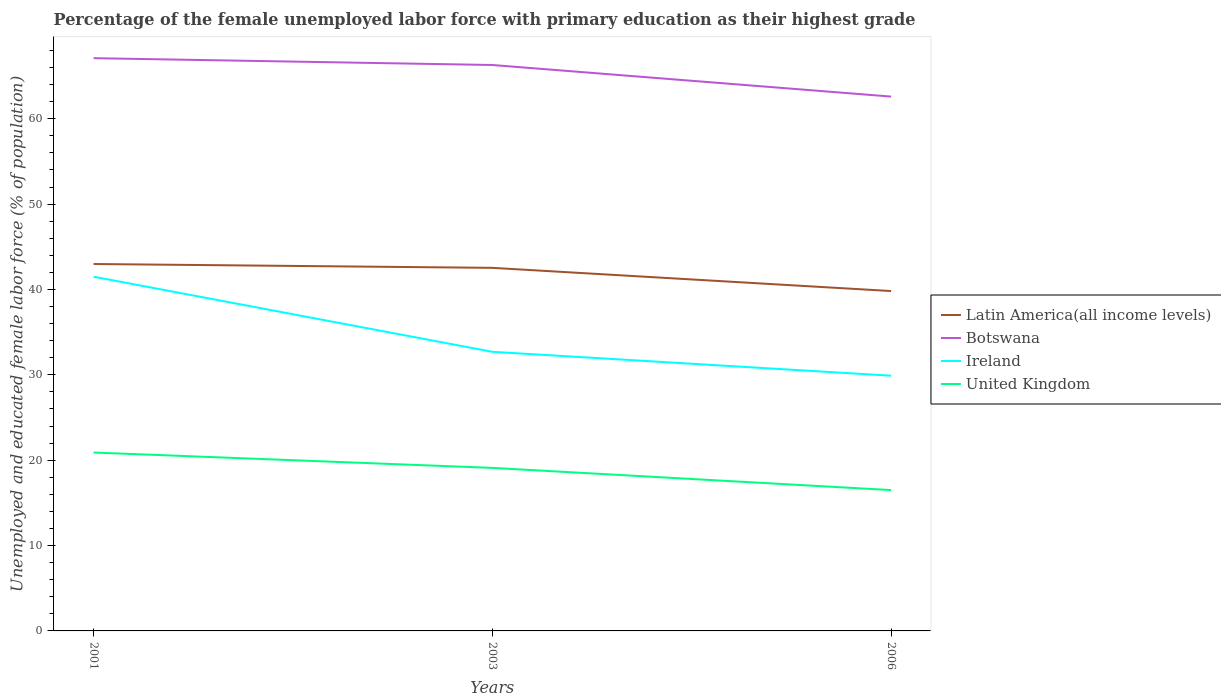How many different coloured lines are there?
Ensure brevity in your answer.  4. Does the line corresponding to United Kingdom intersect with the line corresponding to Ireland?
Your answer should be compact. No. In which year was the percentage of the unemployed female labor force with primary education in United Kingdom maximum?
Keep it short and to the point. 2006. What is the total percentage of the unemployed female labor force with primary education in Latin America(all income levels) in the graph?
Your answer should be compact. 3.17. What is the difference between the highest and the second highest percentage of the unemployed female labor force with primary education in Ireland?
Make the answer very short. 11.6. Is the percentage of the unemployed female labor force with primary education in Botswana strictly greater than the percentage of the unemployed female labor force with primary education in Ireland over the years?
Offer a very short reply. No. What is the difference between two consecutive major ticks on the Y-axis?
Your response must be concise. 10. Does the graph contain grids?
Give a very brief answer. No. How many legend labels are there?
Provide a succinct answer. 4. What is the title of the graph?
Ensure brevity in your answer.  Percentage of the female unemployed labor force with primary education as their highest grade. What is the label or title of the Y-axis?
Keep it short and to the point. Unemployed and educated female labor force (% of population). What is the Unemployed and educated female labor force (% of population) in Latin America(all income levels) in 2001?
Provide a short and direct response. 42.99. What is the Unemployed and educated female labor force (% of population) of Botswana in 2001?
Provide a short and direct response. 67.1. What is the Unemployed and educated female labor force (% of population) of Ireland in 2001?
Ensure brevity in your answer.  41.5. What is the Unemployed and educated female labor force (% of population) of United Kingdom in 2001?
Provide a succinct answer. 20.9. What is the Unemployed and educated female labor force (% of population) of Latin America(all income levels) in 2003?
Give a very brief answer. 42.54. What is the Unemployed and educated female labor force (% of population) of Botswana in 2003?
Keep it short and to the point. 66.3. What is the Unemployed and educated female labor force (% of population) in Ireland in 2003?
Keep it short and to the point. 32.7. What is the Unemployed and educated female labor force (% of population) in United Kingdom in 2003?
Your answer should be compact. 19.1. What is the Unemployed and educated female labor force (% of population) in Latin America(all income levels) in 2006?
Make the answer very short. 39.82. What is the Unemployed and educated female labor force (% of population) in Botswana in 2006?
Offer a terse response. 62.6. What is the Unemployed and educated female labor force (% of population) in Ireland in 2006?
Give a very brief answer. 29.9. What is the Unemployed and educated female labor force (% of population) in United Kingdom in 2006?
Your response must be concise. 16.5. Across all years, what is the maximum Unemployed and educated female labor force (% of population) of Latin America(all income levels)?
Your answer should be very brief. 42.99. Across all years, what is the maximum Unemployed and educated female labor force (% of population) in Botswana?
Your answer should be very brief. 67.1. Across all years, what is the maximum Unemployed and educated female labor force (% of population) in Ireland?
Ensure brevity in your answer.  41.5. Across all years, what is the maximum Unemployed and educated female labor force (% of population) of United Kingdom?
Offer a terse response. 20.9. Across all years, what is the minimum Unemployed and educated female labor force (% of population) in Latin America(all income levels)?
Provide a succinct answer. 39.82. Across all years, what is the minimum Unemployed and educated female labor force (% of population) in Botswana?
Offer a terse response. 62.6. Across all years, what is the minimum Unemployed and educated female labor force (% of population) of Ireland?
Offer a very short reply. 29.9. What is the total Unemployed and educated female labor force (% of population) in Latin America(all income levels) in the graph?
Ensure brevity in your answer.  125.34. What is the total Unemployed and educated female labor force (% of population) of Botswana in the graph?
Keep it short and to the point. 196. What is the total Unemployed and educated female labor force (% of population) of Ireland in the graph?
Provide a succinct answer. 104.1. What is the total Unemployed and educated female labor force (% of population) in United Kingdom in the graph?
Your answer should be compact. 56.5. What is the difference between the Unemployed and educated female labor force (% of population) of Latin America(all income levels) in 2001 and that in 2003?
Offer a terse response. 0.45. What is the difference between the Unemployed and educated female labor force (% of population) of Ireland in 2001 and that in 2003?
Ensure brevity in your answer.  8.8. What is the difference between the Unemployed and educated female labor force (% of population) in United Kingdom in 2001 and that in 2003?
Offer a very short reply. 1.8. What is the difference between the Unemployed and educated female labor force (% of population) of Latin America(all income levels) in 2001 and that in 2006?
Your answer should be compact. 3.17. What is the difference between the Unemployed and educated female labor force (% of population) in Botswana in 2001 and that in 2006?
Give a very brief answer. 4.5. What is the difference between the Unemployed and educated female labor force (% of population) of Latin America(all income levels) in 2003 and that in 2006?
Ensure brevity in your answer.  2.72. What is the difference between the Unemployed and educated female labor force (% of population) of Botswana in 2003 and that in 2006?
Ensure brevity in your answer.  3.7. What is the difference between the Unemployed and educated female labor force (% of population) of United Kingdom in 2003 and that in 2006?
Offer a very short reply. 2.6. What is the difference between the Unemployed and educated female labor force (% of population) of Latin America(all income levels) in 2001 and the Unemployed and educated female labor force (% of population) of Botswana in 2003?
Your answer should be very brief. -23.31. What is the difference between the Unemployed and educated female labor force (% of population) in Latin America(all income levels) in 2001 and the Unemployed and educated female labor force (% of population) in Ireland in 2003?
Offer a terse response. 10.29. What is the difference between the Unemployed and educated female labor force (% of population) in Latin America(all income levels) in 2001 and the Unemployed and educated female labor force (% of population) in United Kingdom in 2003?
Your answer should be very brief. 23.89. What is the difference between the Unemployed and educated female labor force (% of population) of Botswana in 2001 and the Unemployed and educated female labor force (% of population) of Ireland in 2003?
Your answer should be very brief. 34.4. What is the difference between the Unemployed and educated female labor force (% of population) of Ireland in 2001 and the Unemployed and educated female labor force (% of population) of United Kingdom in 2003?
Your answer should be compact. 22.4. What is the difference between the Unemployed and educated female labor force (% of population) of Latin America(all income levels) in 2001 and the Unemployed and educated female labor force (% of population) of Botswana in 2006?
Make the answer very short. -19.61. What is the difference between the Unemployed and educated female labor force (% of population) in Latin America(all income levels) in 2001 and the Unemployed and educated female labor force (% of population) in Ireland in 2006?
Give a very brief answer. 13.09. What is the difference between the Unemployed and educated female labor force (% of population) of Latin America(all income levels) in 2001 and the Unemployed and educated female labor force (% of population) of United Kingdom in 2006?
Offer a terse response. 26.49. What is the difference between the Unemployed and educated female labor force (% of population) of Botswana in 2001 and the Unemployed and educated female labor force (% of population) of Ireland in 2006?
Make the answer very short. 37.2. What is the difference between the Unemployed and educated female labor force (% of population) in Botswana in 2001 and the Unemployed and educated female labor force (% of population) in United Kingdom in 2006?
Offer a very short reply. 50.6. What is the difference between the Unemployed and educated female labor force (% of population) of Ireland in 2001 and the Unemployed and educated female labor force (% of population) of United Kingdom in 2006?
Keep it short and to the point. 25. What is the difference between the Unemployed and educated female labor force (% of population) of Latin America(all income levels) in 2003 and the Unemployed and educated female labor force (% of population) of Botswana in 2006?
Provide a succinct answer. -20.06. What is the difference between the Unemployed and educated female labor force (% of population) in Latin America(all income levels) in 2003 and the Unemployed and educated female labor force (% of population) in Ireland in 2006?
Your answer should be compact. 12.64. What is the difference between the Unemployed and educated female labor force (% of population) of Latin America(all income levels) in 2003 and the Unemployed and educated female labor force (% of population) of United Kingdom in 2006?
Offer a terse response. 26.04. What is the difference between the Unemployed and educated female labor force (% of population) of Botswana in 2003 and the Unemployed and educated female labor force (% of population) of Ireland in 2006?
Make the answer very short. 36.4. What is the difference between the Unemployed and educated female labor force (% of population) of Botswana in 2003 and the Unemployed and educated female labor force (% of population) of United Kingdom in 2006?
Your answer should be very brief. 49.8. What is the difference between the Unemployed and educated female labor force (% of population) in Ireland in 2003 and the Unemployed and educated female labor force (% of population) in United Kingdom in 2006?
Provide a short and direct response. 16.2. What is the average Unemployed and educated female labor force (% of population) in Latin America(all income levels) per year?
Your answer should be very brief. 41.78. What is the average Unemployed and educated female labor force (% of population) in Botswana per year?
Provide a succinct answer. 65.33. What is the average Unemployed and educated female labor force (% of population) of Ireland per year?
Offer a very short reply. 34.7. What is the average Unemployed and educated female labor force (% of population) of United Kingdom per year?
Make the answer very short. 18.83. In the year 2001, what is the difference between the Unemployed and educated female labor force (% of population) in Latin America(all income levels) and Unemployed and educated female labor force (% of population) in Botswana?
Your response must be concise. -24.11. In the year 2001, what is the difference between the Unemployed and educated female labor force (% of population) of Latin America(all income levels) and Unemployed and educated female labor force (% of population) of Ireland?
Keep it short and to the point. 1.49. In the year 2001, what is the difference between the Unemployed and educated female labor force (% of population) in Latin America(all income levels) and Unemployed and educated female labor force (% of population) in United Kingdom?
Ensure brevity in your answer.  22.09. In the year 2001, what is the difference between the Unemployed and educated female labor force (% of population) of Botswana and Unemployed and educated female labor force (% of population) of Ireland?
Keep it short and to the point. 25.6. In the year 2001, what is the difference between the Unemployed and educated female labor force (% of population) of Botswana and Unemployed and educated female labor force (% of population) of United Kingdom?
Offer a very short reply. 46.2. In the year 2001, what is the difference between the Unemployed and educated female labor force (% of population) in Ireland and Unemployed and educated female labor force (% of population) in United Kingdom?
Ensure brevity in your answer.  20.6. In the year 2003, what is the difference between the Unemployed and educated female labor force (% of population) of Latin America(all income levels) and Unemployed and educated female labor force (% of population) of Botswana?
Ensure brevity in your answer.  -23.76. In the year 2003, what is the difference between the Unemployed and educated female labor force (% of population) of Latin America(all income levels) and Unemployed and educated female labor force (% of population) of Ireland?
Ensure brevity in your answer.  9.84. In the year 2003, what is the difference between the Unemployed and educated female labor force (% of population) in Latin America(all income levels) and Unemployed and educated female labor force (% of population) in United Kingdom?
Give a very brief answer. 23.44. In the year 2003, what is the difference between the Unemployed and educated female labor force (% of population) in Botswana and Unemployed and educated female labor force (% of population) in Ireland?
Provide a succinct answer. 33.6. In the year 2003, what is the difference between the Unemployed and educated female labor force (% of population) in Botswana and Unemployed and educated female labor force (% of population) in United Kingdom?
Offer a terse response. 47.2. In the year 2006, what is the difference between the Unemployed and educated female labor force (% of population) in Latin America(all income levels) and Unemployed and educated female labor force (% of population) in Botswana?
Give a very brief answer. -22.78. In the year 2006, what is the difference between the Unemployed and educated female labor force (% of population) of Latin America(all income levels) and Unemployed and educated female labor force (% of population) of Ireland?
Provide a succinct answer. 9.92. In the year 2006, what is the difference between the Unemployed and educated female labor force (% of population) in Latin America(all income levels) and Unemployed and educated female labor force (% of population) in United Kingdom?
Keep it short and to the point. 23.32. In the year 2006, what is the difference between the Unemployed and educated female labor force (% of population) in Botswana and Unemployed and educated female labor force (% of population) in Ireland?
Your answer should be very brief. 32.7. In the year 2006, what is the difference between the Unemployed and educated female labor force (% of population) in Botswana and Unemployed and educated female labor force (% of population) in United Kingdom?
Your answer should be very brief. 46.1. What is the ratio of the Unemployed and educated female labor force (% of population) in Latin America(all income levels) in 2001 to that in 2003?
Offer a very short reply. 1.01. What is the ratio of the Unemployed and educated female labor force (% of population) of Botswana in 2001 to that in 2003?
Your answer should be very brief. 1.01. What is the ratio of the Unemployed and educated female labor force (% of population) of Ireland in 2001 to that in 2003?
Ensure brevity in your answer.  1.27. What is the ratio of the Unemployed and educated female labor force (% of population) of United Kingdom in 2001 to that in 2003?
Ensure brevity in your answer.  1.09. What is the ratio of the Unemployed and educated female labor force (% of population) of Latin America(all income levels) in 2001 to that in 2006?
Ensure brevity in your answer.  1.08. What is the ratio of the Unemployed and educated female labor force (% of population) in Botswana in 2001 to that in 2006?
Provide a succinct answer. 1.07. What is the ratio of the Unemployed and educated female labor force (% of population) of Ireland in 2001 to that in 2006?
Offer a very short reply. 1.39. What is the ratio of the Unemployed and educated female labor force (% of population) in United Kingdom in 2001 to that in 2006?
Keep it short and to the point. 1.27. What is the ratio of the Unemployed and educated female labor force (% of population) in Latin America(all income levels) in 2003 to that in 2006?
Keep it short and to the point. 1.07. What is the ratio of the Unemployed and educated female labor force (% of population) of Botswana in 2003 to that in 2006?
Give a very brief answer. 1.06. What is the ratio of the Unemployed and educated female labor force (% of population) in Ireland in 2003 to that in 2006?
Make the answer very short. 1.09. What is the ratio of the Unemployed and educated female labor force (% of population) in United Kingdom in 2003 to that in 2006?
Offer a terse response. 1.16. What is the difference between the highest and the second highest Unemployed and educated female labor force (% of population) in Latin America(all income levels)?
Ensure brevity in your answer.  0.45. What is the difference between the highest and the second highest Unemployed and educated female labor force (% of population) in Botswana?
Ensure brevity in your answer.  0.8. What is the difference between the highest and the second highest Unemployed and educated female labor force (% of population) in United Kingdom?
Offer a very short reply. 1.8. What is the difference between the highest and the lowest Unemployed and educated female labor force (% of population) of Latin America(all income levels)?
Offer a terse response. 3.17. What is the difference between the highest and the lowest Unemployed and educated female labor force (% of population) in Botswana?
Your answer should be very brief. 4.5. What is the difference between the highest and the lowest Unemployed and educated female labor force (% of population) of Ireland?
Your response must be concise. 11.6. What is the difference between the highest and the lowest Unemployed and educated female labor force (% of population) of United Kingdom?
Your answer should be compact. 4.4. 